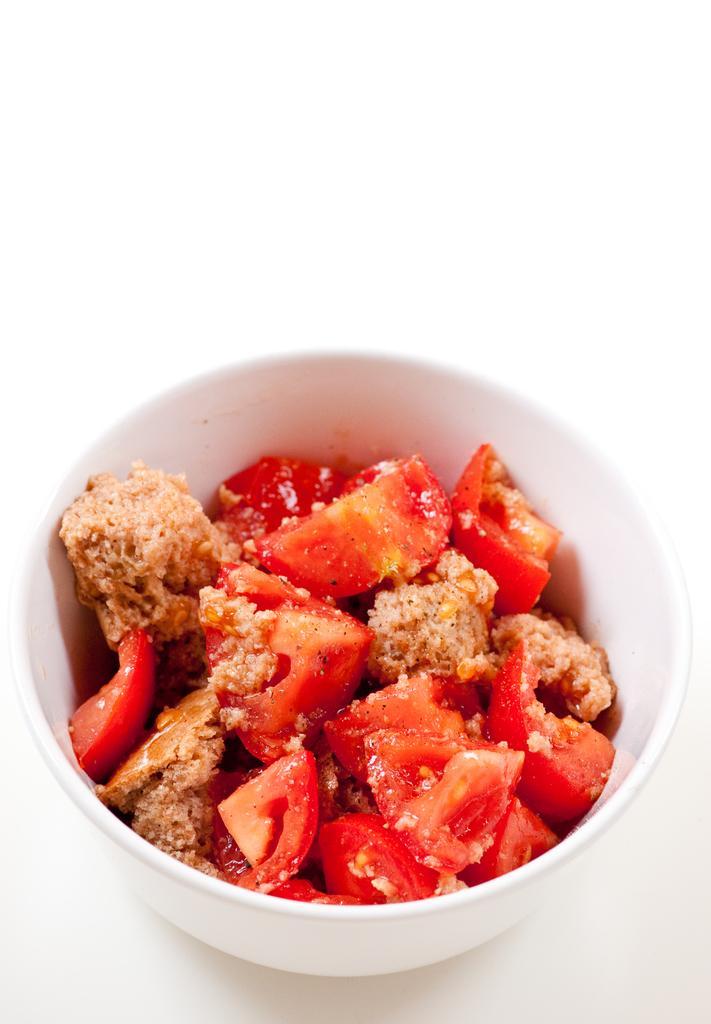Could you give a brief overview of what you see in this image? In this image we can see a bowl containing food placed on the surface. 